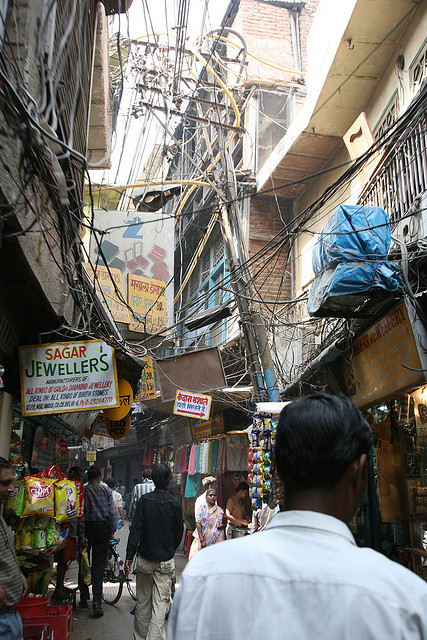Please transcribe the text information in this image. SAGAR JEWELLERS 